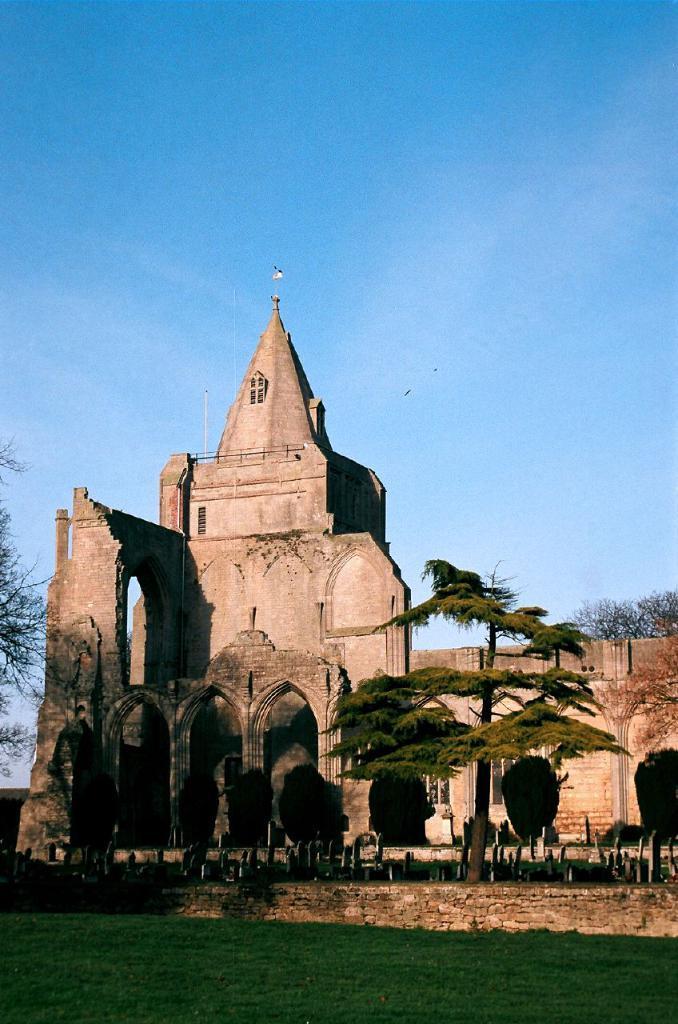In one or two sentences, can you explain what this image depicts? In this picture we can see few trees, grass and a building. 